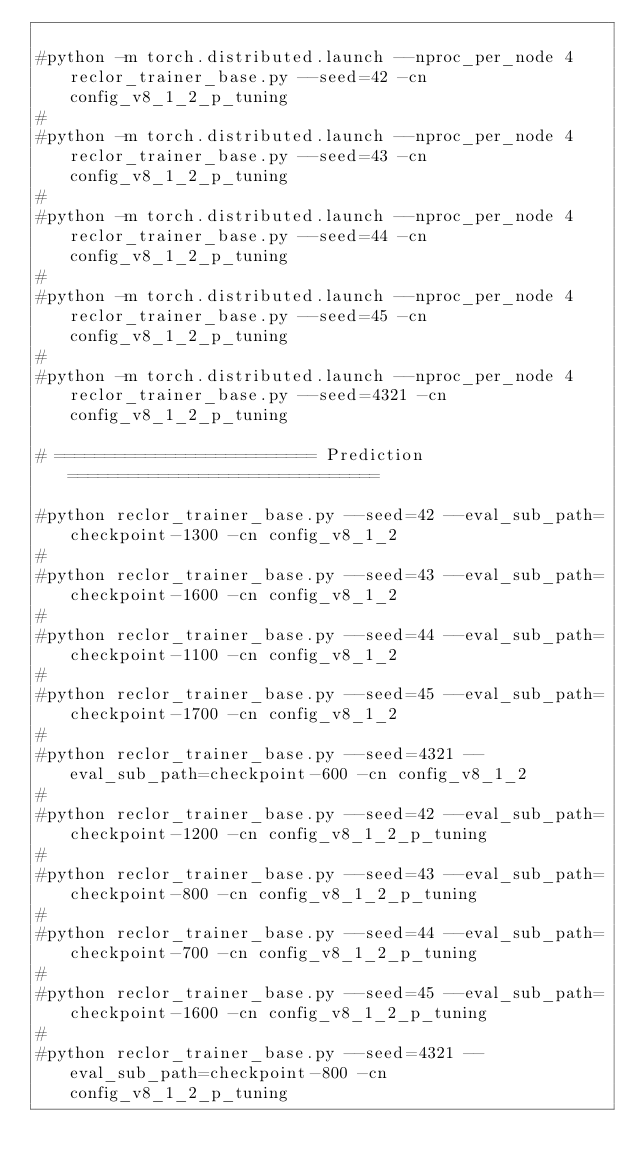<code> <loc_0><loc_0><loc_500><loc_500><_Bash_>
#python -m torch.distributed.launch --nproc_per_node 4 reclor_trainer_base.py --seed=42 -cn config_v8_1_2_p_tuning
#
#python -m torch.distributed.launch --nproc_per_node 4 reclor_trainer_base.py --seed=43 -cn config_v8_1_2_p_tuning
#
#python -m torch.distributed.launch --nproc_per_node 4 reclor_trainer_base.py --seed=44 -cn config_v8_1_2_p_tuning
#
#python -m torch.distributed.launch --nproc_per_node 4 reclor_trainer_base.py --seed=45 -cn config_v8_1_2_p_tuning
#
#python -m torch.distributed.launch --nproc_per_node 4 reclor_trainer_base.py --seed=4321 -cn config_v8_1_2_p_tuning

# ========================== Prediction ===============================

#python reclor_trainer_base.py --seed=42 --eval_sub_path=checkpoint-1300 -cn config_v8_1_2
#
#python reclor_trainer_base.py --seed=43 --eval_sub_path=checkpoint-1600 -cn config_v8_1_2
#
#python reclor_trainer_base.py --seed=44 --eval_sub_path=checkpoint-1100 -cn config_v8_1_2
#
#python reclor_trainer_base.py --seed=45 --eval_sub_path=checkpoint-1700 -cn config_v8_1_2
#
#python reclor_trainer_base.py --seed=4321 --eval_sub_path=checkpoint-600 -cn config_v8_1_2
#
#python reclor_trainer_base.py --seed=42 --eval_sub_path=checkpoint-1200 -cn config_v8_1_2_p_tuning
#
#python reclor_trainer_base.py --seed=43 --eval_sub_path=checkpoint-800 -cn config_v8_1_2_p_tuning
#
#python reclor_trainer_base.py --seed=44 --eval_sub_path=checkpoint-700 -cn config_v8_1_2_p_tuning
#
#python reclor_trainer_base.py --seed=45 --eval_sub_path=checkpoint-1600 -cn config_v8_1_2_p_tuning
#
#python reclor_trainer_base.py --seed=4321 --eval_sub_path=checkpoint-800 -cn config_v8_1_2_p_tuning
</code> 